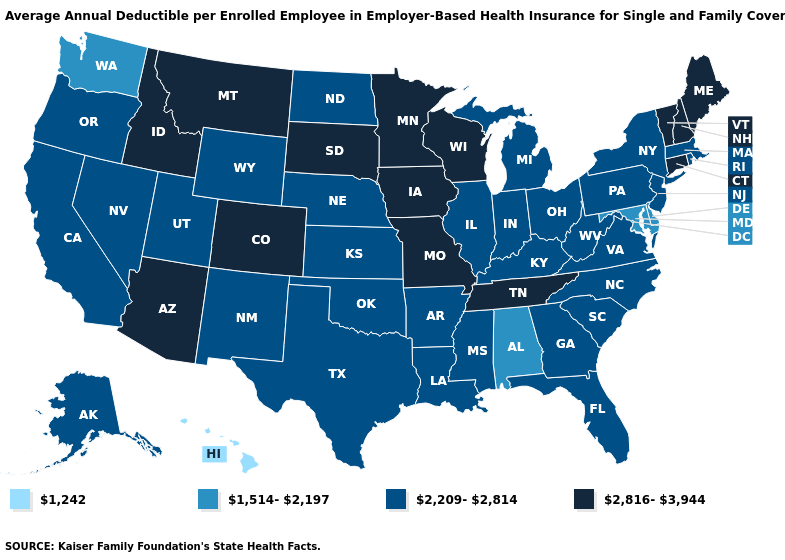Does Missouri have the highest value in the USA?
Give a very brief answer. Yes. What is the highest value in the USA?
Write a very short answer. 2,816-3,944. What is the highest value in the USA?
Give a very brief answer. 2,816-3,944. What is the highest value in the South ?
Give a very brief answer. 2,816-3,944. What is the lowest value in the USA?
Be succinct. 1,242. Name the states that have a value in the range 1,242?
Short answer required. Hawaii. What is the value of Indiana?
Quick response, please. 2,209-2,814. What is the value of Arkansas?
Answer briefly. 2,209-2,814. Among the states that border Colorado , does Oklahoma have the lowest value?
Answer briefly. Yes. Which states have the highest value in the USA?
Write a very short answer. Arizona, Colorado, Connecticut, Idaho, Iowa, Maine, Minnesota, Missouri, Montana, New Hampshire, South Dakota, Tennessee, Vermont, Wisconsin. What is the lowest value in the USA?
Be succinct. 1,242. What is the lowest value in the USA?
Quick response, please. 1,242. What is the value of Kansas?
Write a very short answer. 2,209-2,814. Which states have the highest value in the USA?
Answer briefly. Arizona, Colorado, Connecticut, Idaho, Iowa, Maine, Minnesota, Missouri, Montana, New Hampshire, South Dakota, Tennessee, Vermont, Wisconsin. Does the first symbol in the legend represent the smallest category?
Concise answer only. Yes. 